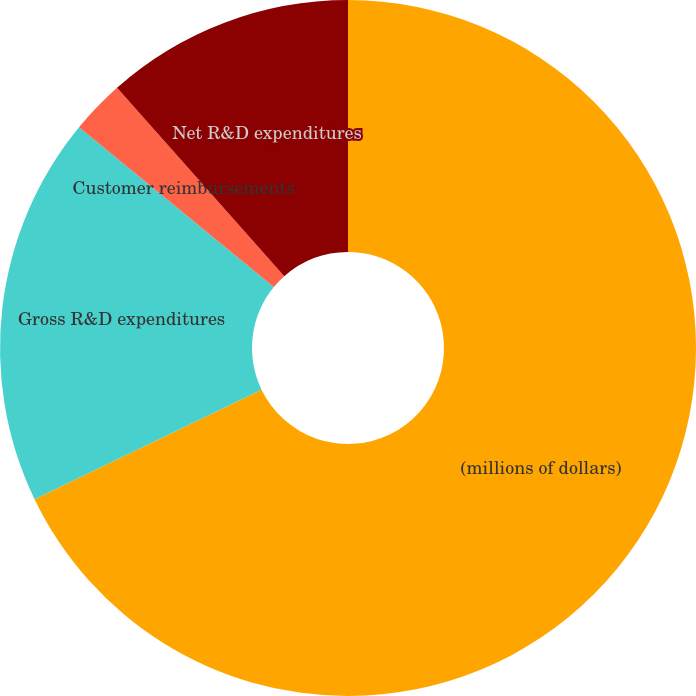Convert chart to OTSL. <chart><loc_0><loc_0><loc_500><loc_500><pie_chart><fcel>(millions of dollars)<fcel>Gross R&D expenditures<fcel>Customer reimbursements<fcel>Net R&D expenditures<nl><fcel>67.85%<fcel>18.09%<fcel>2.51%<fcel>11.55%<nl></chart> 